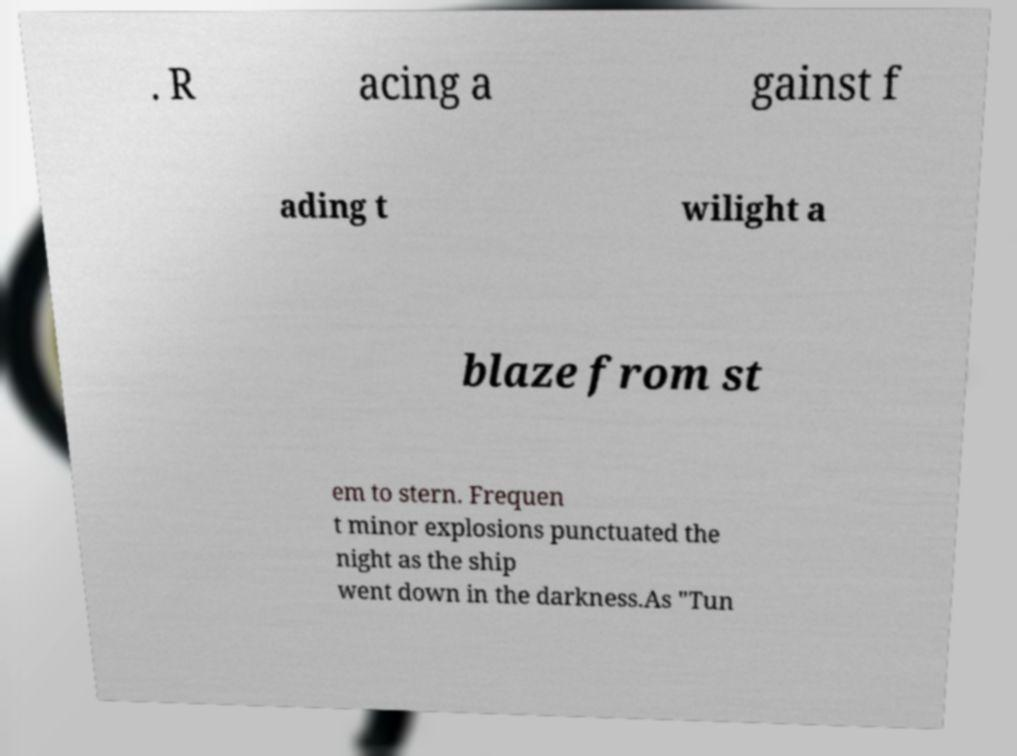There's text embedded in this image that I need extracted. Can you transcribe it verbatim? . R acing a gainst f ading t wilight a blaze from st em to stern. Frequen t minor explosions punctuated the night as the ship went down in the darkness.As "Tun 